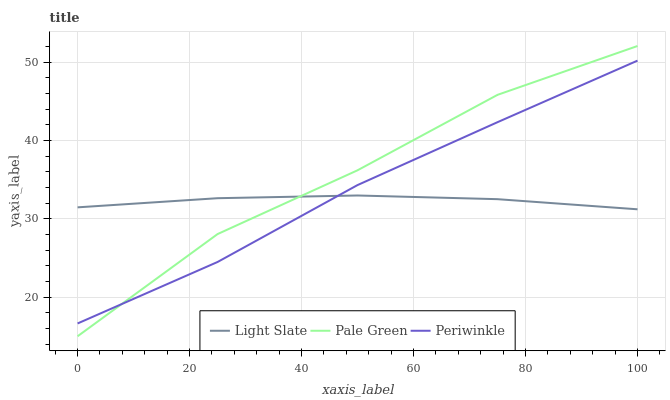Does Light Slate have the minimum area under the curve?
Answer yes or no. Yes. Does Pale Green have the maximum area under the curve?
Answer yes or no. Yes. Does Periwinkle have the minimum area under the curve?
Answer yes or no. No. Does Periwinkle have the maximum area under the curve?
Answer yes or no. No. Is Light Slate the smoothest?
Answer yes or no. Yes. Is Pale Green the roughest?
Answer yes or no. Yes. Is Periwinkle the smoothest?
Answer yes or no. No. Is Periwinkle the roughest?
Answer yes or no. No. Does Pale Green have the lowest value?
Answer yes or no. Yes. Does Periwinkle have the lowest value?
Answer yes or no. No. Does Pale Green have the highest value?
Answer yes or no. Yes. Does Periwinkle have the highest value?
Answer yes or no. No. Does Pale Green intersect Periwinkle?
Answer yes or no. Yes. Is Pale Green less than Periwinkle?
Answer yes or no. No. Is Pale Green greater than Periwinkle?
Answer yes or no. No. 